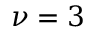Convert formula to latex. <formula><loc_0><loc_0><loc_500><loc_500>\nu = 3</formula> 